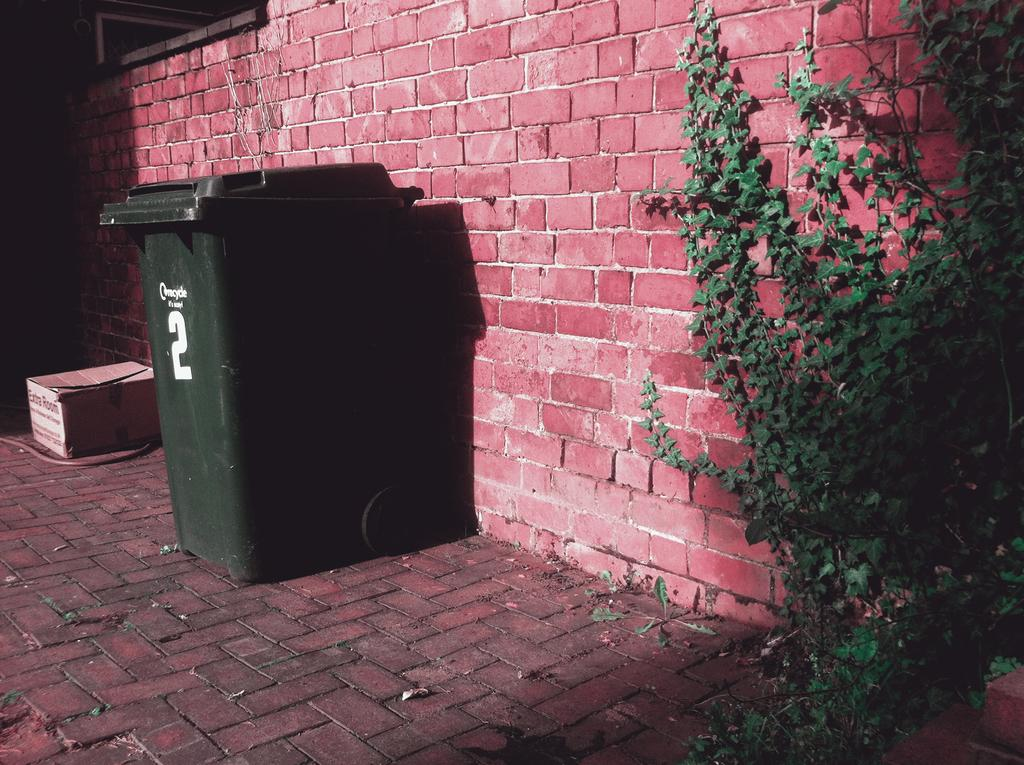<image>
Relay a brief, clear account of the picture shown. A green container with number 2 sits against a red brick wall. 